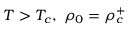<formula> <loc_0><loc_0><loc_500><loc_500>T > T _ { c } , \ \rho _ { 0 } = \rho _ { c } ^ { + }</formula> 